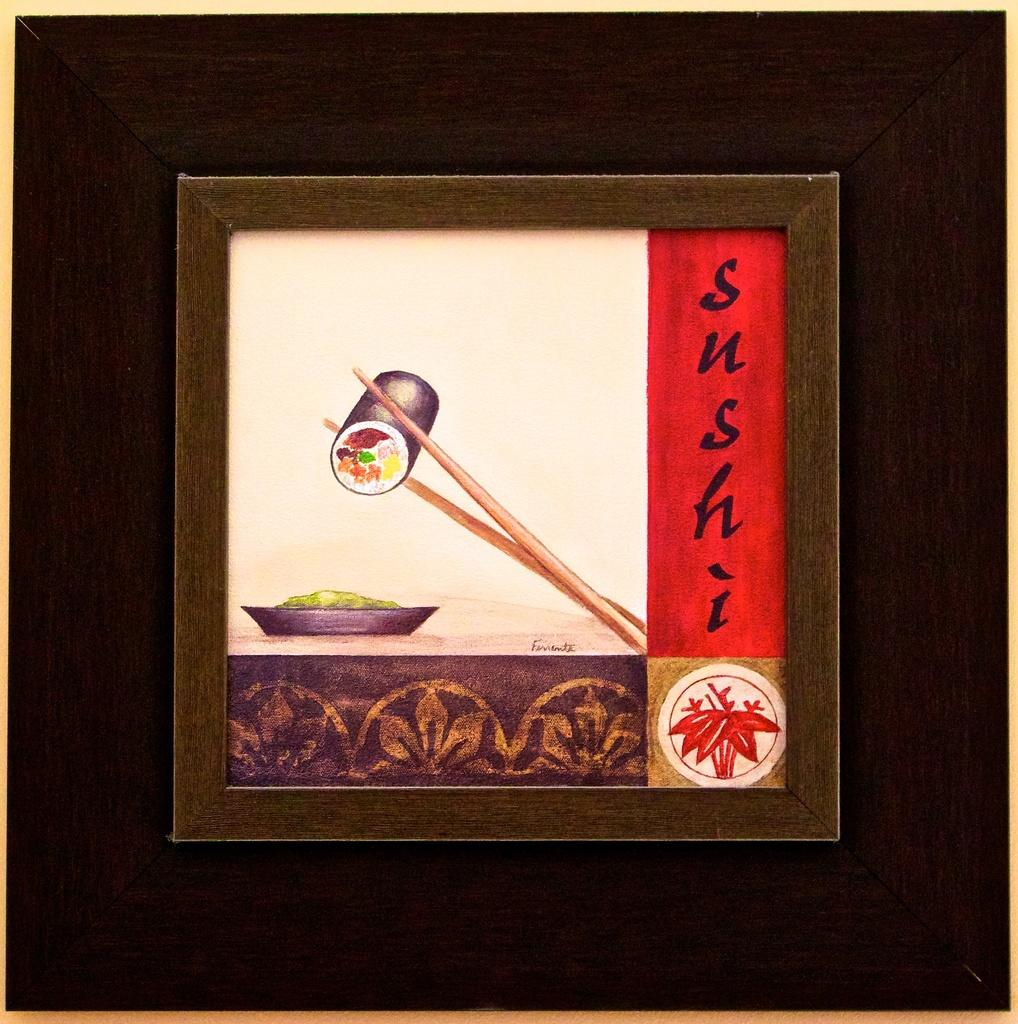<image>
Summarize the visual content of the image. A framed piece of art with a picture and label of sushi. 